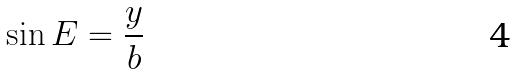Convert formula to latex. <formula><loc_0><loc_0><loc_500><loc_500>\sin E = \frac { y } { b }</formula> 